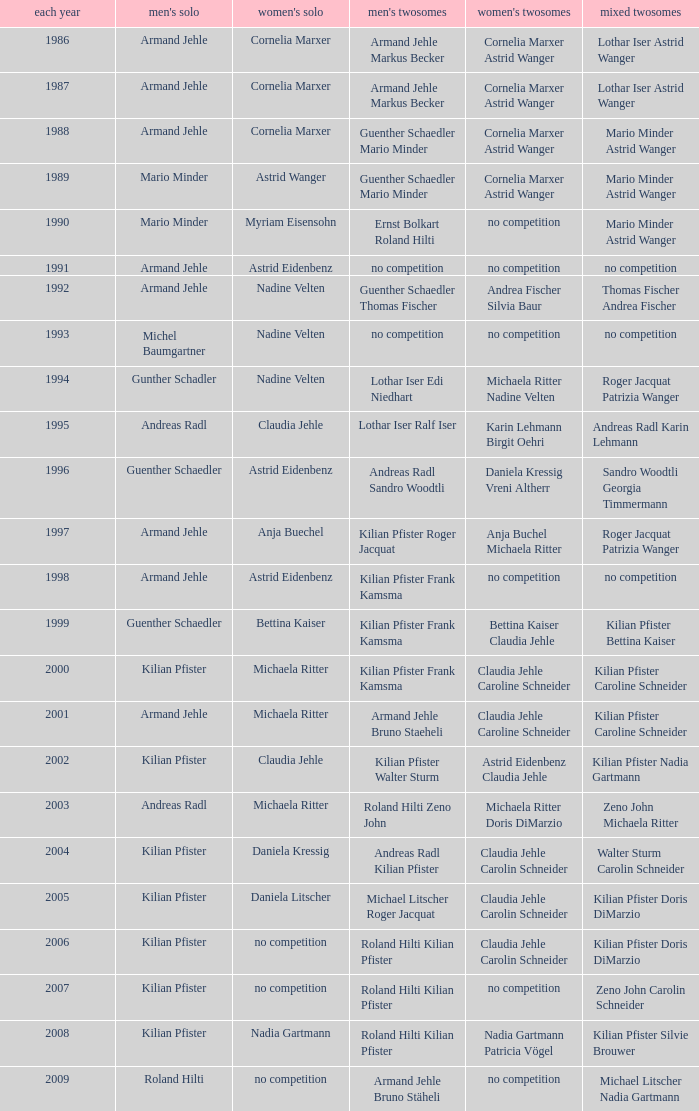In 2004, where the womens singles is daniela kressig who is the mens singles Kilian Pfister. 